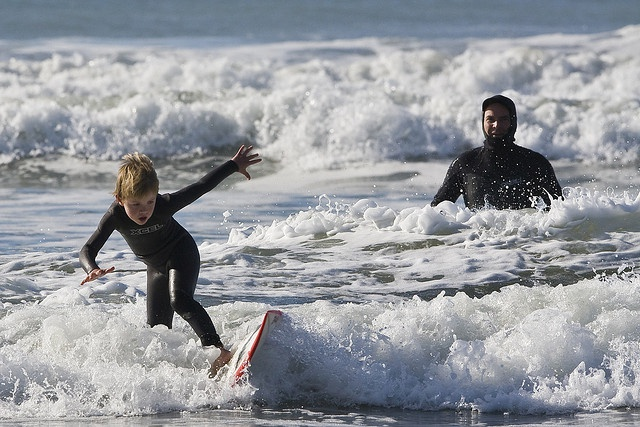Describe the objects in this image and their specific colors. I can see people in gray, black, and darkgray tones, people in gray, black, darkgray, and lightgray tones, and surfboard in gray, lightgray, darkgray, and maroon tones in this image. 